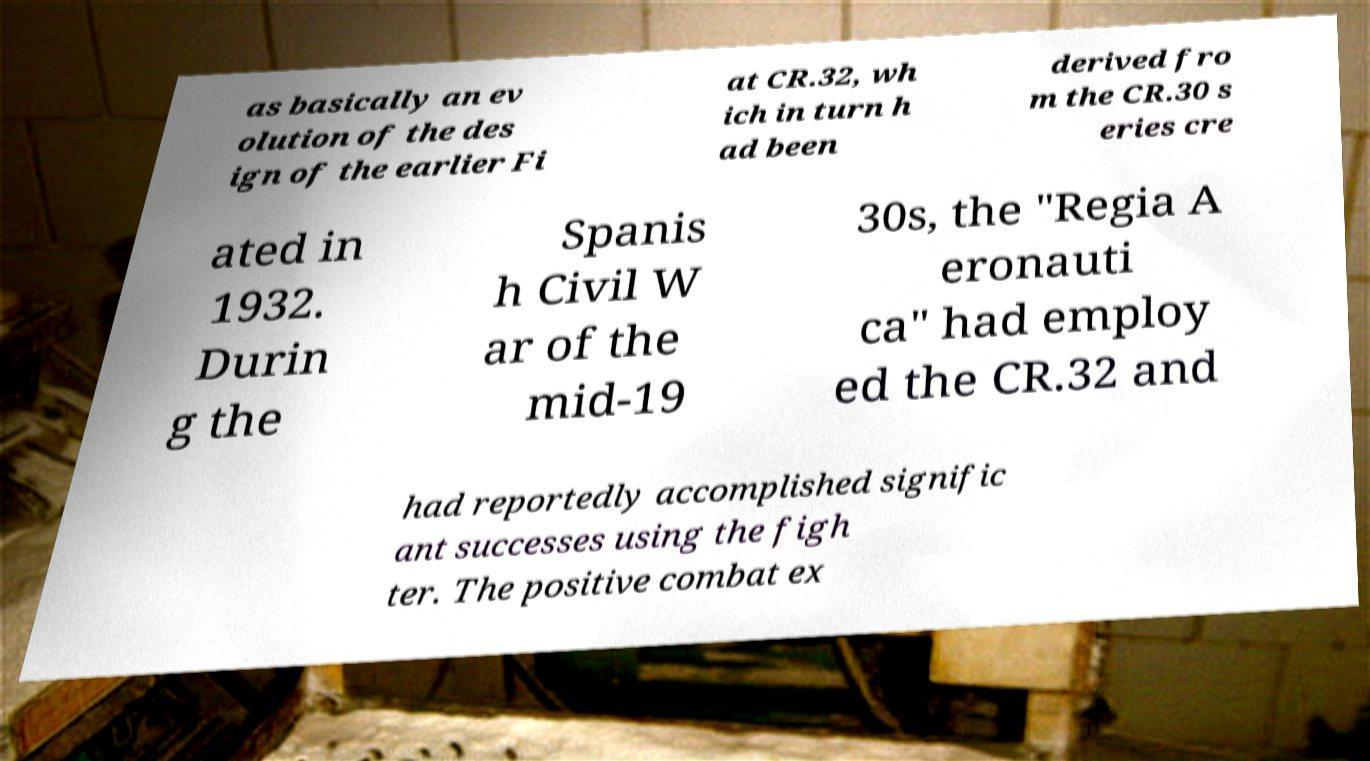I need the written content from this picture converted into text. Can you do that? as basically an ev olution of the des ign of the earlier Fi at CR.32, wh ich in turn h ad been derived fro m the CR.30 s eries cre ated in 1932. Durin g the Spanis h Civil W ar of the mid-19 30s, the "Regia A eronauti ca" had employ ed the CR.32 and had reportedly accomplished signific ant successes using the figh ter. The positive combat ex 